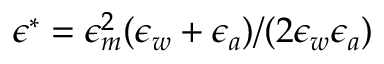Convert formula to latex. <formula><loc_0><loc_0><loc_500><loc_500>\epsilon ^ { * } = \epsilon _ { m } ^ { 2 } ( \epsilon _ { w } + \epsilon _ { a } ) / ( 2 \epsilon _ { w } \epsilon _ { a } )</formula> 